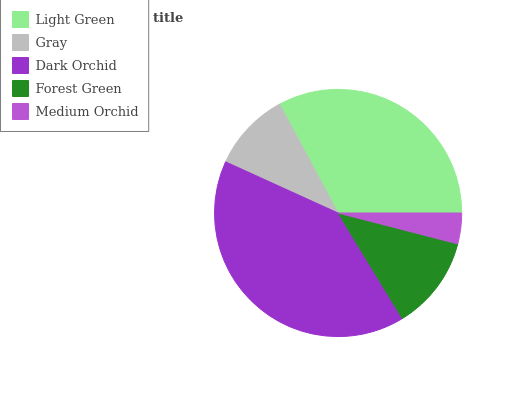Is Medium Orchid the minimum?
Answer yes or no. Yes. Is Dark Orchid the maximum?
Answer yes or no. Yes. Is Gray the minimum?
Answer yes or no. No. Is Gray the maximum?
Answer yes or no. No. Is Light Green greater than Gray?
Answer yes or no. Yes. Is Gray less than Light Green?
Answer yes or no. Yes. Is Gray greater than Light Green?
Answer yes or no. No. Is Light Green less than Gray?
Answer yes or no. No. Is Forest Green the high median?
Answer yes or no. Yes. Is Forest Green the low median?
Answer yes or no. Yes. Is Dark Orchid the high median?
Answer yes or no. No. Is Dark Orchid the low median?
Answer yes or no. No. 